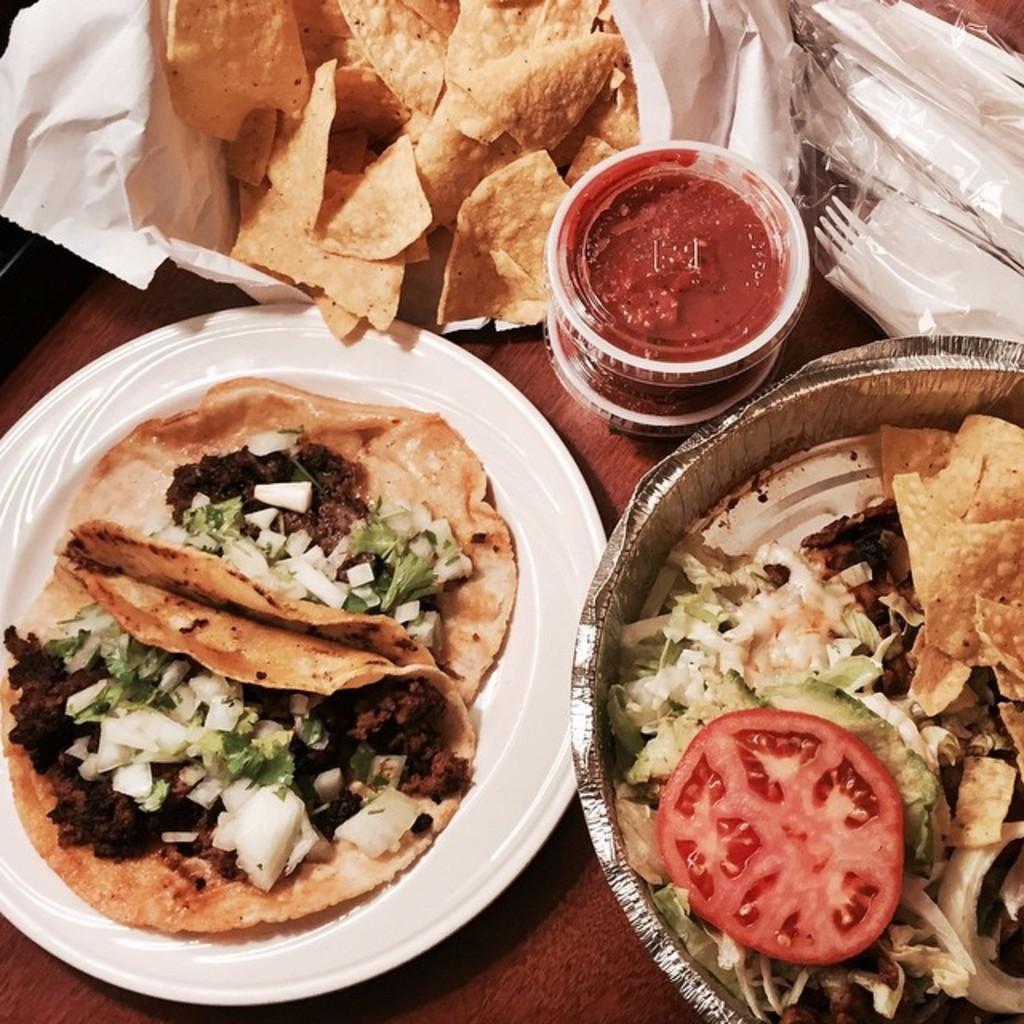Describe this image in one or two sentences. On the table we can see chips, bottle, caps, white plates, spoons, fork, tissue papers and plastic cover. In a white plate we can see bread and other food pieces. On the right we can see tomato chips, cabbages and other food items in a bowl. 